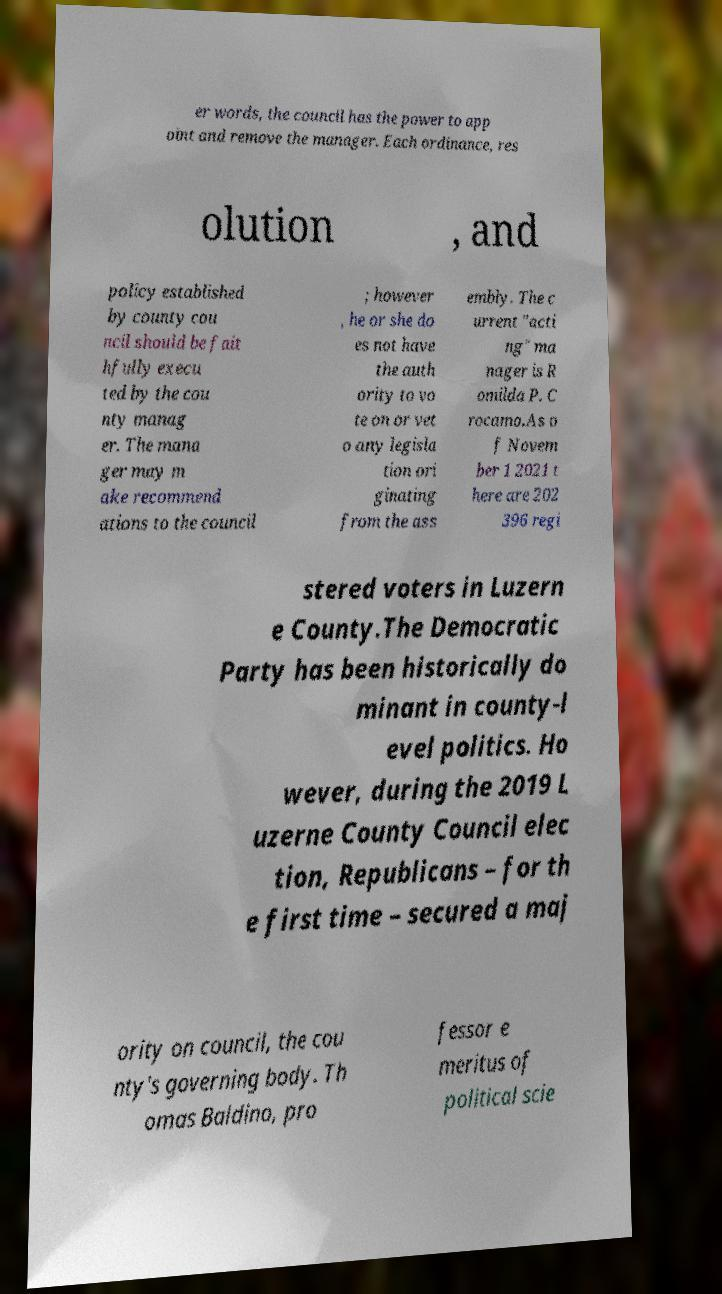Could you extract and type out the text from this image? er words, the council has the power to app oint and remove the manager. Each ordinance, res olution , and policy established by county cou ncil should be fait hfully execu ted by the cou nty manag er. The mana ger may m ake recommend ations to the council ; however , he or she do es not have the auth ority to vo te on or vet o any legisla tion ori ginating from the ass embly. The c urrent "acti ng" ma nager is R omilda P. C rocamo.As o f Novem ber 1 2021 t here are 202 396 regi stered voters in Luzern e County.The Democratic Party has been historically do minant in county-l evel politics. Ho wever, during the 2019 L uzerne County Council elec tion, Republicans – for th e first time – secured a maj ority on council, the cou nty's governing body. Th omas Baldino, pro fessor e meritus of political scie 